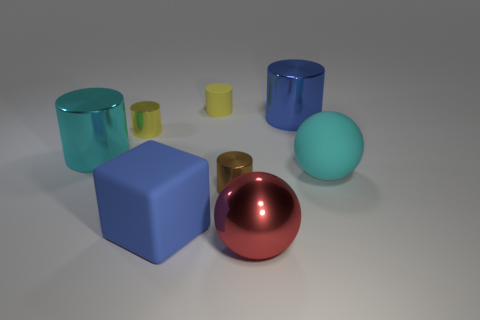What is the shape of the shiny thing that is the same color as the small rubber cylinder?
Keep it short and to the point. Cylinder. Are the big cylinder on the right side of the small brown cylinder and the brown cylinder made of the same material?
Offer a terse response. Yes. The other tiny rubber thing that is the same shape as the tiny brown thing is what color?
Keep it short and to the point. Yellow. Is there any other thing that has the same shape as the large blue rubber thing?
Your answer should be very brief. No. Are there an equal number of matte cubes left of the yellow matte thing and large objects?
Provide a succinct answer. No. There is a cyan sphere; are there any small brown metal cylinders in front of it?
Your response must be concise. Yes. There is a blue thing in front of the shiny thing that is to the right of the ball that is on the left side of the big blue metallic object; how big is it?
Offer a very short reply. Large. Do the small metallic thing that is right of the block and the big object left of the blue cube have the same shape?
Make the answer very short. Yes. There is a blue metallic object that is the same shape as the small yellow rubber object; what is its size?
Keep it short and to the point. Large. What number of small brown things have the same material as the big blue cylinder?
Provide a short and direct response. 1. 